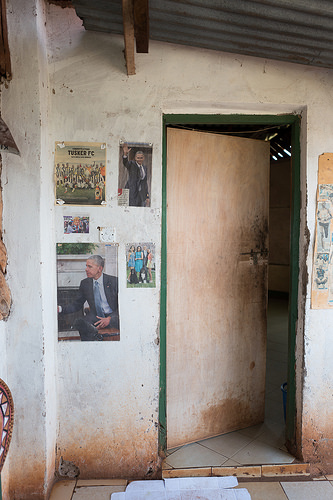<image>
Can you confirm if the obama is next to the wall? No. The obama is not positioned next to the wall. They are located in different areas of the scene. 